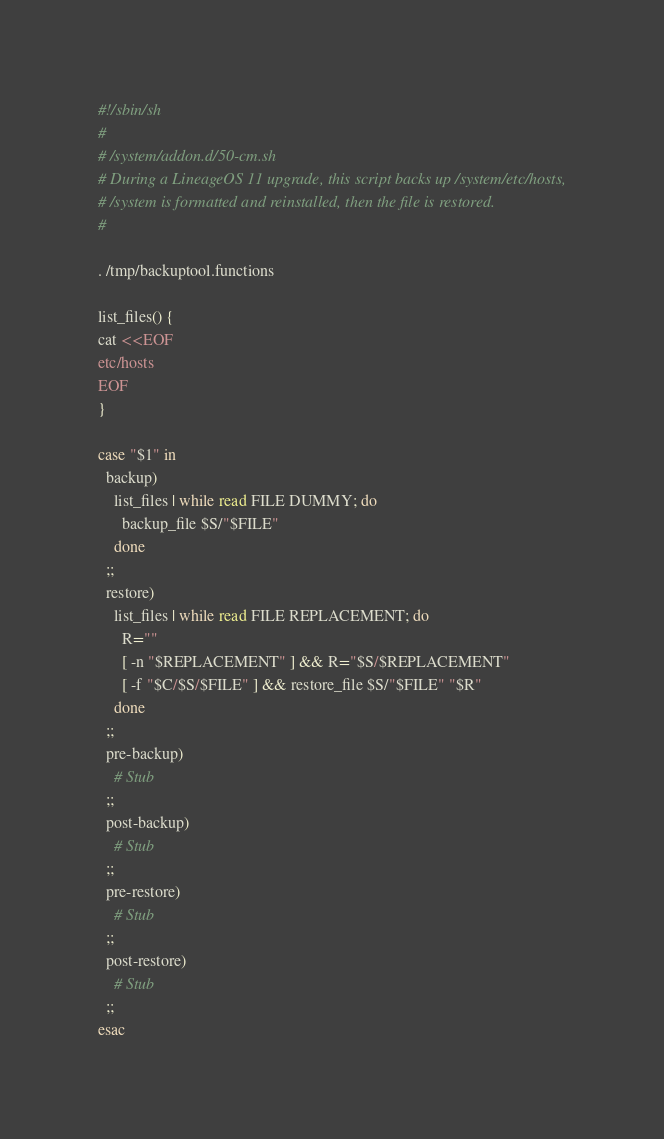<code> <loc_0><loc_0><loc_500><loc_500><_Bash_>#!/sbin/sh
# 
# /system/addon.d/50-cm.sh
# During a LineageOS 11 upgrade, this script backs up /system/etc/hosts,
# /system is formatted and reinstalled, then the file is restored.
#

. /tmp/backuptool.functions

list_files() {
cat <<EOF
etc/hosts
EOF
}

case "$1" in
  backup)
    list_files | while read FILE DUMMY; do
      backup_file $S/"$FILE"
    done
  ;;
  restore)
    list_files | while read FILE REPLACEMENT; do
      R=""
      [ -n "$REPLACEMENT" ] && R="$S/$REPLACEMENT"
      [ -f "$C/$S/$FILE" ] && restore_file $S/"$FILE" "$R"
    done
  ;;
  pre-backup)
    # Stub
  ;;
  post-backup)
    # Stub
  ;;
  pre-restore)
    # Stub
  ;;
  post-restore)
    # Stub
  ;;
esac
</code> 